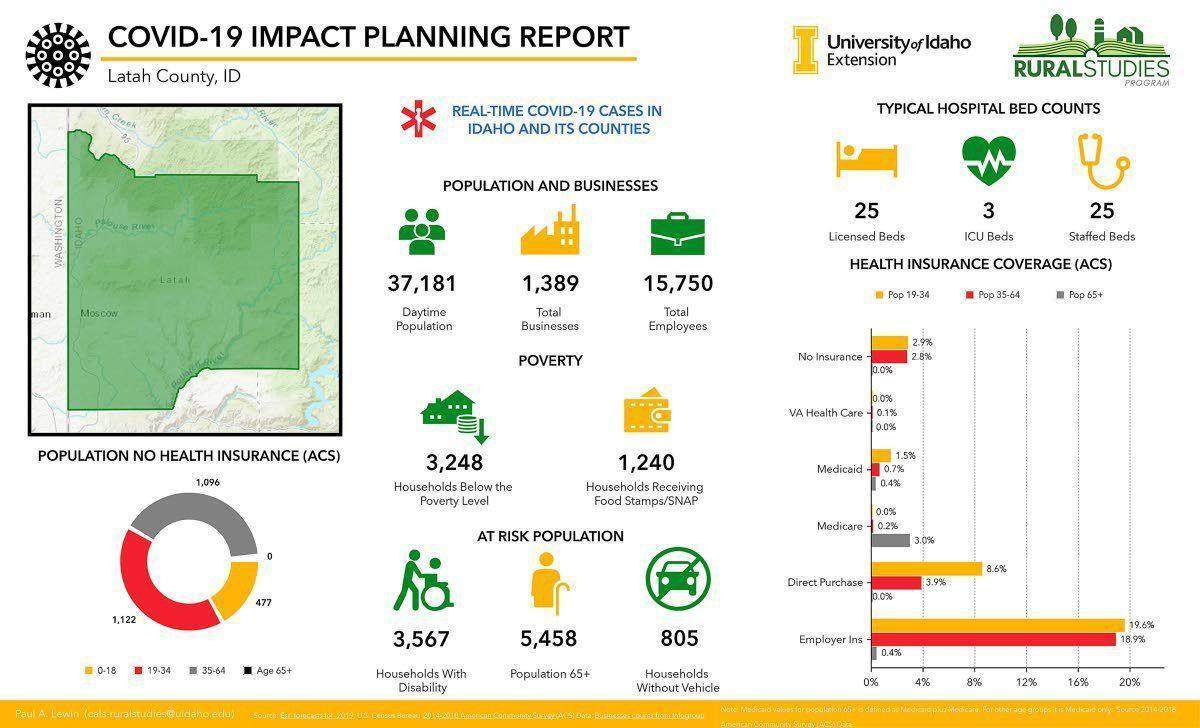What is the total number of diabled as well as senior citizens in Idaho?
Answer the question with a short phrase. 9,025 What percent of population aged 19-34 purchase health insurance directly? 8.6% How many hospital beds are there in total including licensed, ICU and staffed beds? 53 0.7% population of which age group has Medicaid? 35-64 To which age group do 1,122 people with no health insurance belong? 19-34 Which age group is represented by grey in the pie chart? 35-64 How many people in the age group 0-18 do not have health insurance? 477 What percent of senior citizens have Medicaid? 3.0% To what percent of people aged 19-34, do employers provide insurance? 19.6% 